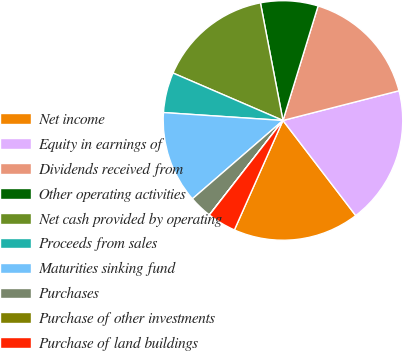Convert chart. <chart><loc_0><loc_0><loc_500><loc_500><pie_chart><fcel>Net income<fcel>Equity in earnings of<fcel>Dividends received from<fcel>Other operating activities<fcel>Net cash provided by operating<fcel>Proceeds from sales<fcel>Maturities sinking fund<fcel>Purchases<fcel>Purchase of other investments<fcel>Purchase of land buildings<nl><fcel>17.04%<fcel>18.59%<fcel>16.27%<fcel>7.75%<fcel>15.5%<fcel>5.43%<fcel>12.4%<fcel>3.11%<fcel>0.01%<fcel>3.88%<nl></chart> 